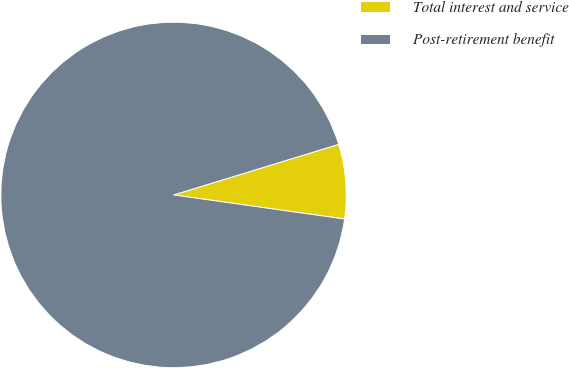<chart> <loc_0><loc_0><loc_500><loc_500><pie_chart><fcel>Total interest and service<fcel>Post-retirement benefit<nl><fcel>6.96%<fcel>93.04%<nl></chart> 